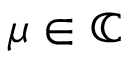Convert formula to latex. <formula><loc_0><loc_0><loc_500><loc_500>\mu \in \mathbb { C }</formula> 